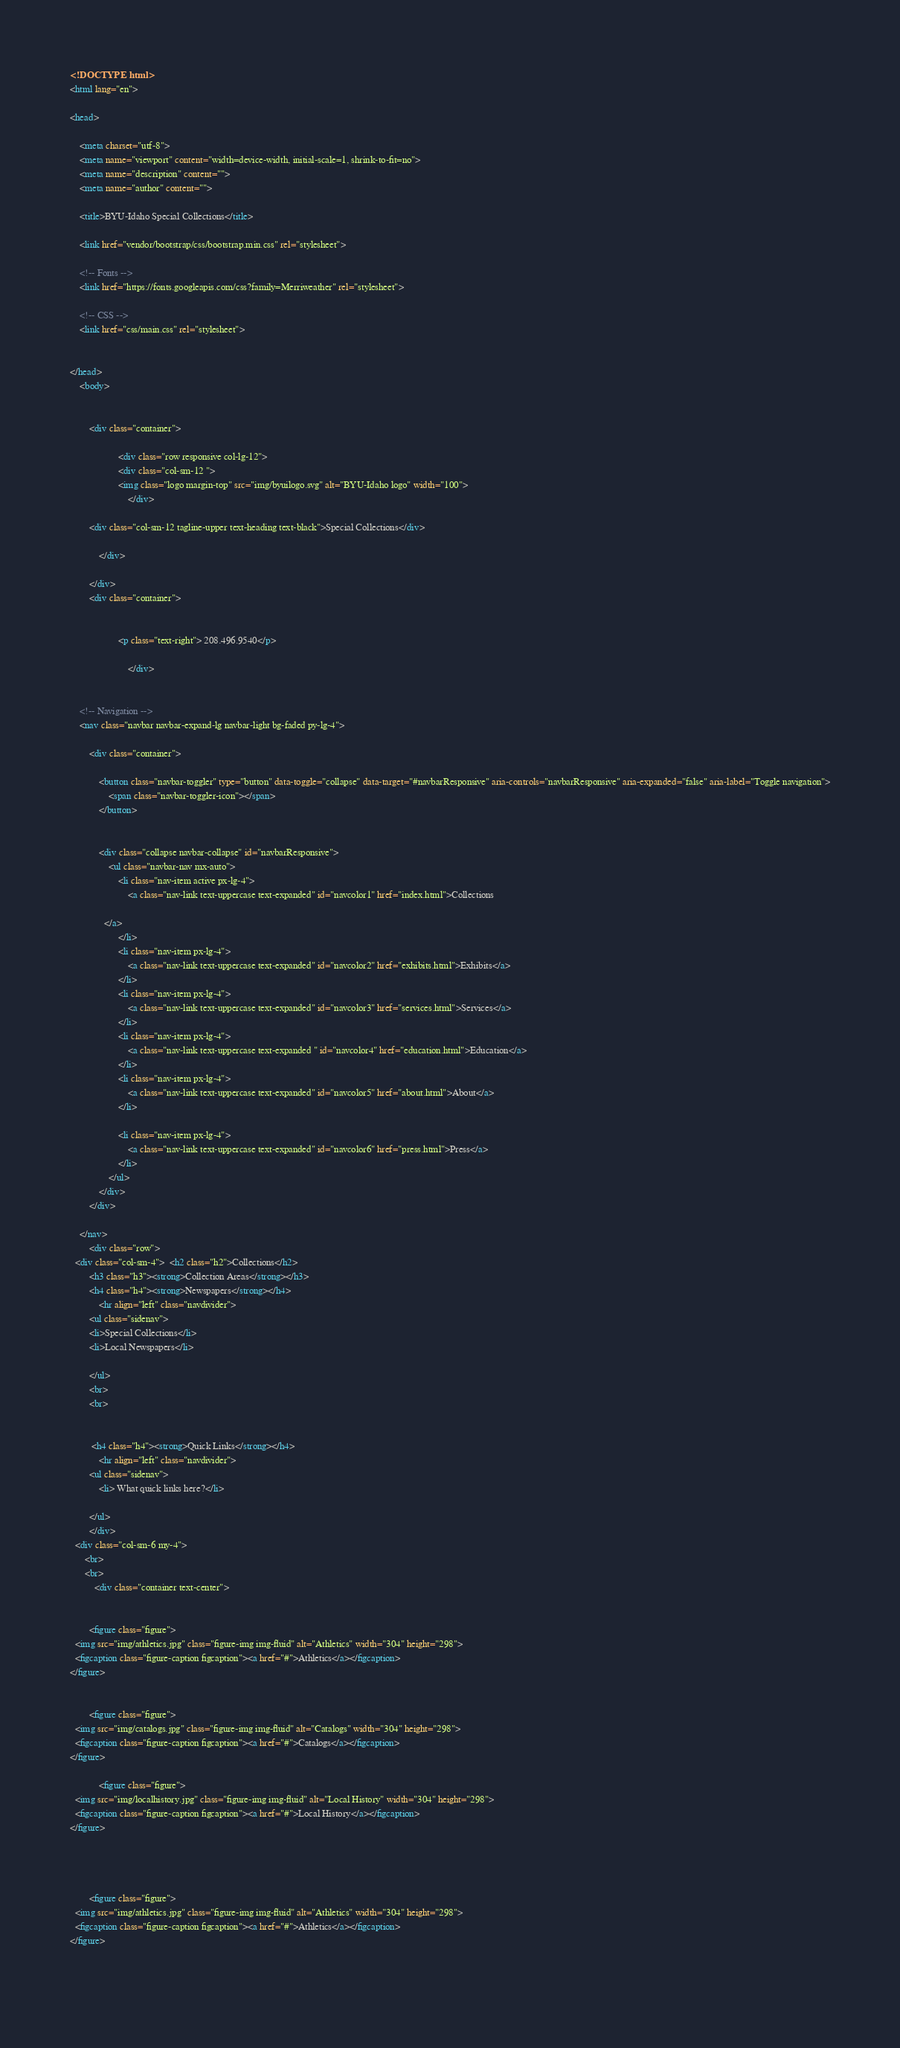Convert code to text. <code><loc_0><loc_0><loc_500><loc_500><_HTML_><!DOCTYPE html>
<html lang="en">

<head>

	<meta charset="utf-8">
	<meta name="viewport" content="width=device-width, initial-scale=1, shrink-to-fit=no">
	<meta name="description" content="">
	<meta name="author" content="">

	<title>BYU-Idaho Special Collections</title>

	<link href="vendor/bootstrap/css/bootstrap.min.css" rel="stylesheet">

	<!-- Fonts -->
	<link href="https://fonts.googleapis.com/css?family=Merriweather" rel="stylesheet">

	<!-- CSS -->
	<link href="css/main.css" rel="stylesheet">

	
</head>
	<body>
        
     
        <div class="container">

					<div class="row responsive col-lg-12"> 
					<div class="col-sm-12 ">
					<img class="logo margin-top" src="img/byuilogo.svg" alt="BYU-Idaho logo" width="100">
						</div>
                       
		<div class="col-sm-12 tagline-upper text-heading text-black">Special Collections</div>
                        
			</div>

		</div>
        <div class="container">

					
					<p class="text-right"> 208.496.9540</p>
            
						</div>


	<!-- Navigation -->
	<nav class="navbar navbar-expand-lg navbar-light bg-faded py-lg-4">

		<div class="container">
			
			<button class="navbar-toggler" type="button" data-toggle="collapse" data-target="#navbarResponsive" aria-controls="navbarResponsive" aria-expanded="false" aria-label="Toggle navigation">
				<span class="navbar-toggler-icon"></span>
			</button>


			<div class="collapse navbar-collapse" id="navbarResponsive">
				<ul class="navbar-nav mx-auto">
					<li class="nav-item active px-lg-4">
						<a class="nav-link text-uppercase text-expanded" id="navcolor1" href="index.html">Collections
                
              </a>
					</li>
					<li class="nav-item px-lg-4">
						<a class="nav-link text-uppercase text-expanded" id="navcolor2" href="exhibits.html">Exhibits</a>
					</li>
					<li class="nav-item px-lg-4">
						<a class="nav-link text-uppercase text-expanded" id="navcolor3" href="services.html">Services</a>
					</li>
					<li class="nav-item px-lg-4">
						<a class="nav-link text-uppercase text-expanded " id="navcolor4" href="education.html">Education</a>
					</li>
					<li class="nav-item px-lg-4">
						<a class="nav-link text-uppercase text-expanded" id="navcolor5" href="about.html">About</a>
					</li>
					
					<li class="nav-item px-lg-4">
						<a class="nav-link text-uppercase text-expanded" id="navcolor6" href="press.html">Press</a>
					</li>
				</ul>
			</div>
		</div>

	</nav>
        <div class="row">
  <div class="col-sm-4">  <h2 class="h2">Collections</h2>
        <h3 class="h3"><strong>Collection Areas</strong></h3>
        <h4 class="h4"><strong>Newspapers</strong></h4>
        	<hr align="left" class="navdivider">
        <ul class="sidenav">
        <li>Special Collections</li>
        <li>Local Newspapers</li>
        
        </ul>
        <br>
        <br>
  
        
         <h4 class="h4"><strong>Quick Links</strong></h4>
        	<hr align="left" class="navdivider">
        <ul class="sidenav">
            <li> What quick links here?</li>
        
        </ul>
		</div>
  <div class="col-sm-6 my-4">
      <br>
      <br>
          <div class="container text-center">
    
		
		<figure class="figure">
  <img src="img/athletics.jpg" class="figure-img img-fluid" alt="Athletics" width="304" height="298">
  <figcaption class="figure-caption figcaption"><a href="#">Athletics</a></figcaption>
</figure>
		
		
		<figure class="figure">
  <img src="img/catalogs.jpg" class="figure-img img-fluid" alt="Catalogs" width="304" height="298">
  <figcaption class="figure-caption figcaption"><a href="#">Catalogs</a></figcaption>
</figure>
		
			<figure class="figure">
  <img src="img/localhistory.jpg" class="figure-img img-fluid" alt="Local History" width="304" height="298">
  <figcaption class="figure-caption figcaption"><a href="#">Local History</a></figcaption>
</figure>
		
	
	
		
		<figure class="figure">
  <img src="img/athletics.jpg" class="figure-img img-fluid" alt="Athletics" width="304" height="298">
  <figcaption class="figure-caption figcaption"><a href="#">Athletics</a></figcaption>
</figure>
		
		</code> 